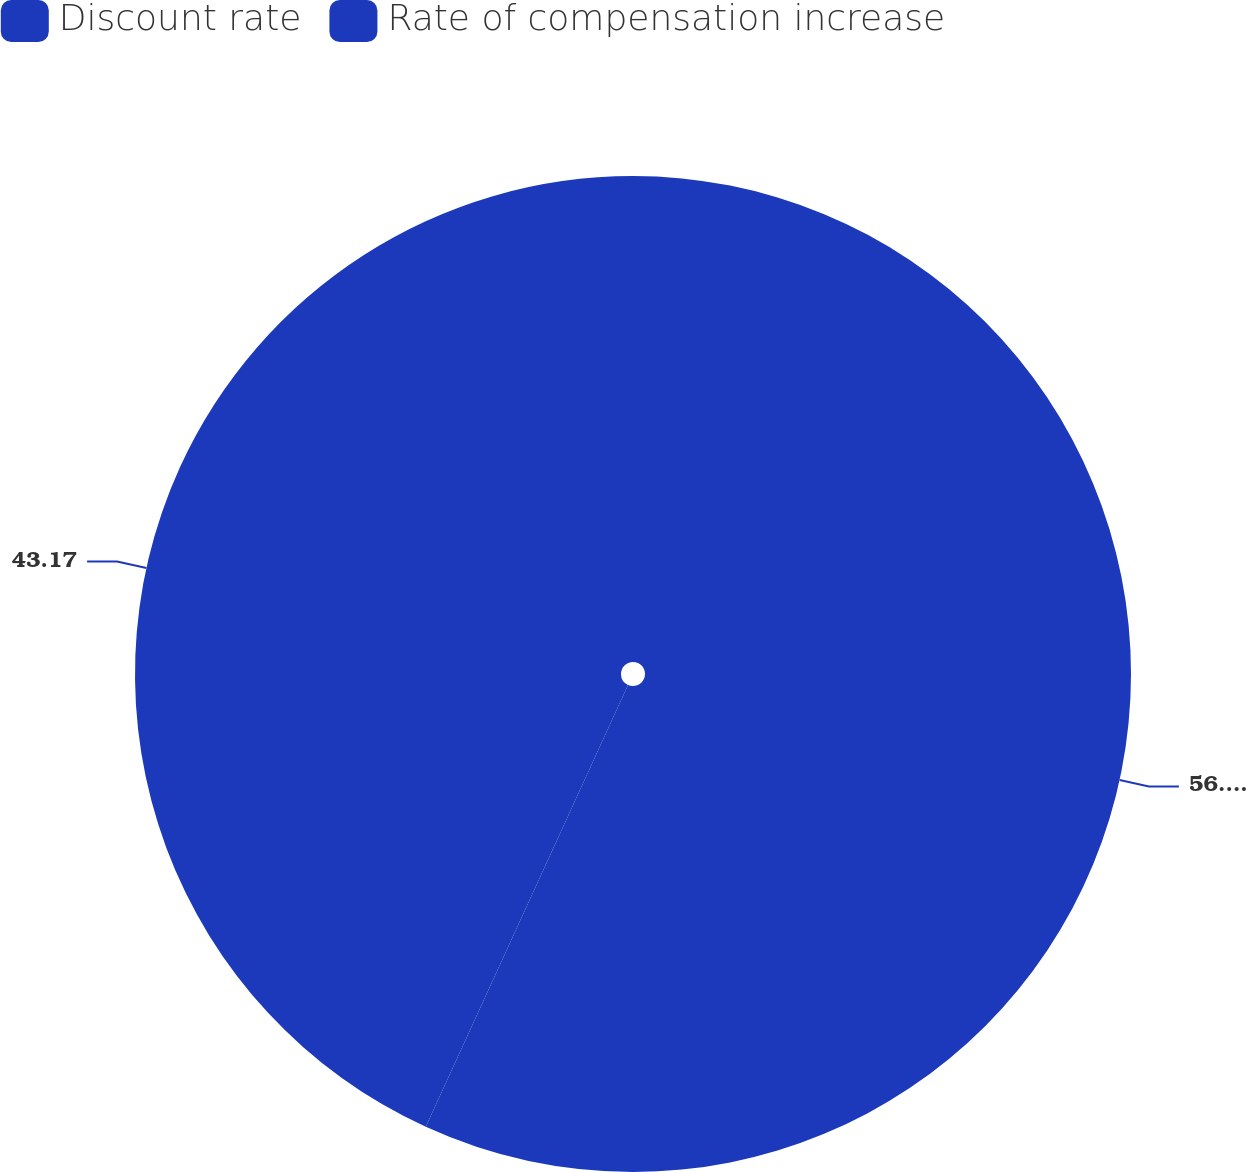Convert chart to OTSL. <chart><loc_0><loc_0><loc_500><loc_500><pie_chart><fcel>Discount rate<fcel>Rate of compensation increase<nl><fcel>56.83%<fcel>43.17%<nl></chart> 